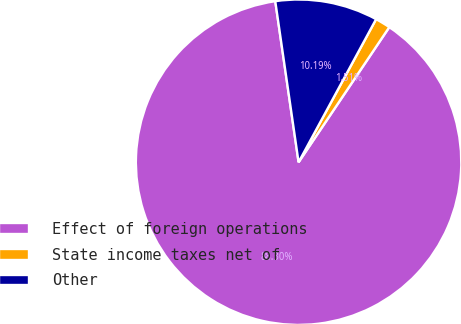Convert chart. <chart><loc_0><loc_0><loc_500><loc_500><pie_chart><fcel>Effect of foreign operations<fcel>State income taxes net of<fcel>Other<nl><fcel>88.29%<fcel>1.51%<fcel>10.19%<nl></chart> 